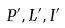<formula> <loc_0><loc_0><loc_500><loc_500>P ^ { \prime } , L ^ { \prime } , I ^ { \prime }</formula> 